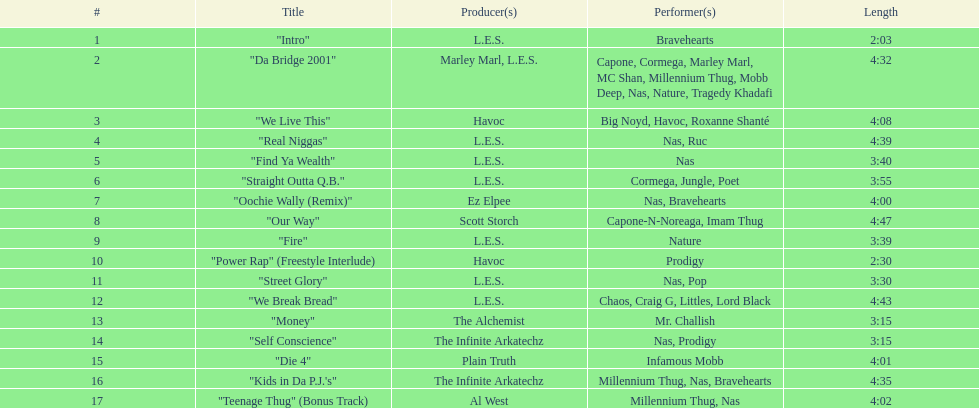Who produced the last track of the album? Al West. Could you help me parse every detail presented in this table? {'header': ['#', 'Title', 'Producer(s)', 'Performer(s)', 'Length'], 'rows': [['1', '"Intro"', 'L.E.S.', 'Bravehearts', '2:03'], ['2', '"Da Bridge 2001"', 'Marley Marl, L.E.S.', 'Capone, Cormega, Marley Marl, MC Shan, Millennium Thug, Mobb Deep, Nas, Nature, Tragedy Khadafi', '4:32'], ['3', '"We Live This"', 'Havoc', 'Big Noyd, Havoc, Roxanne Shanté', '4:08'], ['4', '"Real Niggas"', 'L.E.S.', 'Nas, Ruc', '4:39'], ['5', '"Find Ya Wealth"', 'L.E.S.', 'Nas', '3:40'], ['6', '"Straight Outta Q.B."', 'L.E.S.', 'Cormega, Jungle, Poet', '3:55'], ['7', '"Oochie Wally (Remix)"', 'Ez Elpee', 'Nas, Bravehearts', '4:00'], ['8', '"Our Way"', 'Scott Storch', 'Capone-N-Noreaga, Imam Thug', '4:47'], ['9', '"Fire"', 'L.E.S.', 'Nature', '3:39'], ['10', '"Power Rap" (Freestyle Interlude)', 'Havoc', 'Prodigy', '2:30'], ['11', '"Street Glory"', 'L.E.S.', 'Nas, Pop', '3:30'], ['12', '"We Break Bread"', 'L.E.S.', 'Chaos, Craig G, Littles, Lord Black', '4:43'], ['13', '"Money"', 'The Alchemist', 'Mr. Challish', '3:15'], ['14', '"Self Conscience"', 'The Infinite Arkatechz', 'Nas, Prodigy', '3:15'], ['15', '"Die 4"', 'Plain Truth', 'Infamous Mobb', '4:01'], ['16', '"Kids in Da P.J.\'s"', 'The Infinite Arkatechz', 'Millennium Thug, Nas, Bravehearts', '4:35'], ['17', '"Teenage Thug" (Bonus Track)', 'Al West', 'Millennium Thug, Nas', '4:02']]} 